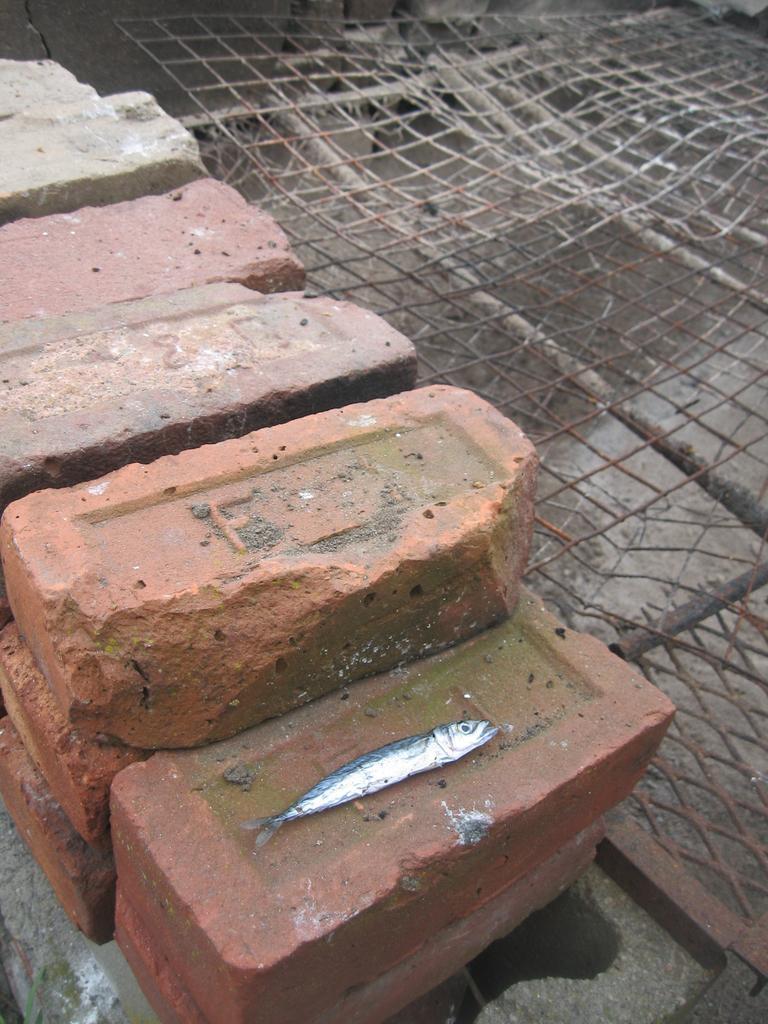How would you summarize this image in a sentence or two? In this picture I can see few bricks and a fish on one of the brick and I can see a metal fence. 